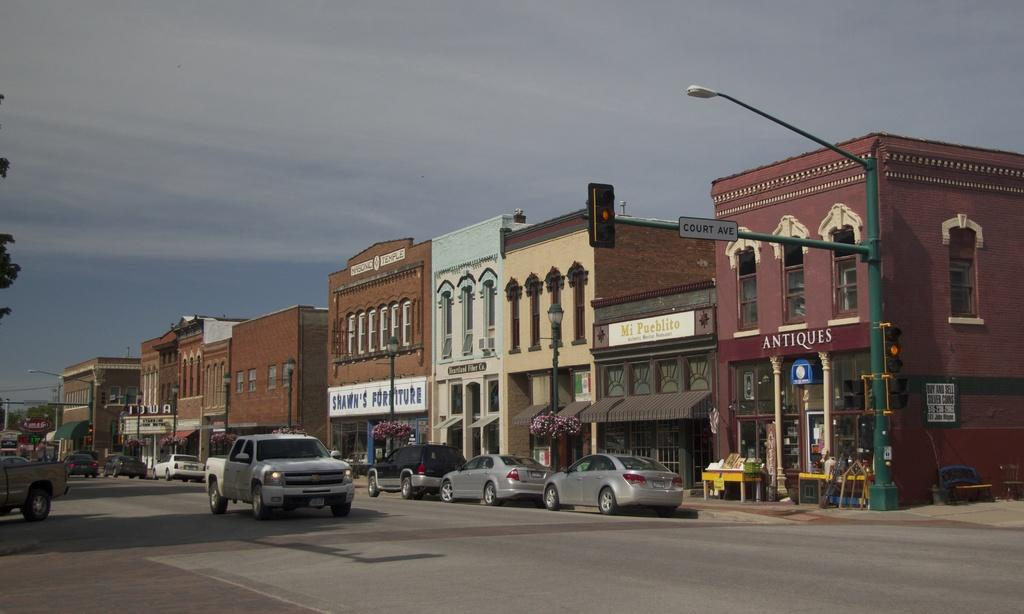What type of structures can be seen in the image? There are buildings in the image. What else can be seen in the image besides the buildings? There are poles and cars on the road at the bottom of the image. What is visible in the background of the image? There is sky visible in the background of the image. Is there any vegetation present in the image? Yes, there is a tree on the left side of the image. What type of ball is being used to fix the error in the image? There is no ball or error present in the image. What is the weather like in the image? The provided facts do not mention the weather, so it cannot be determined from the image. 